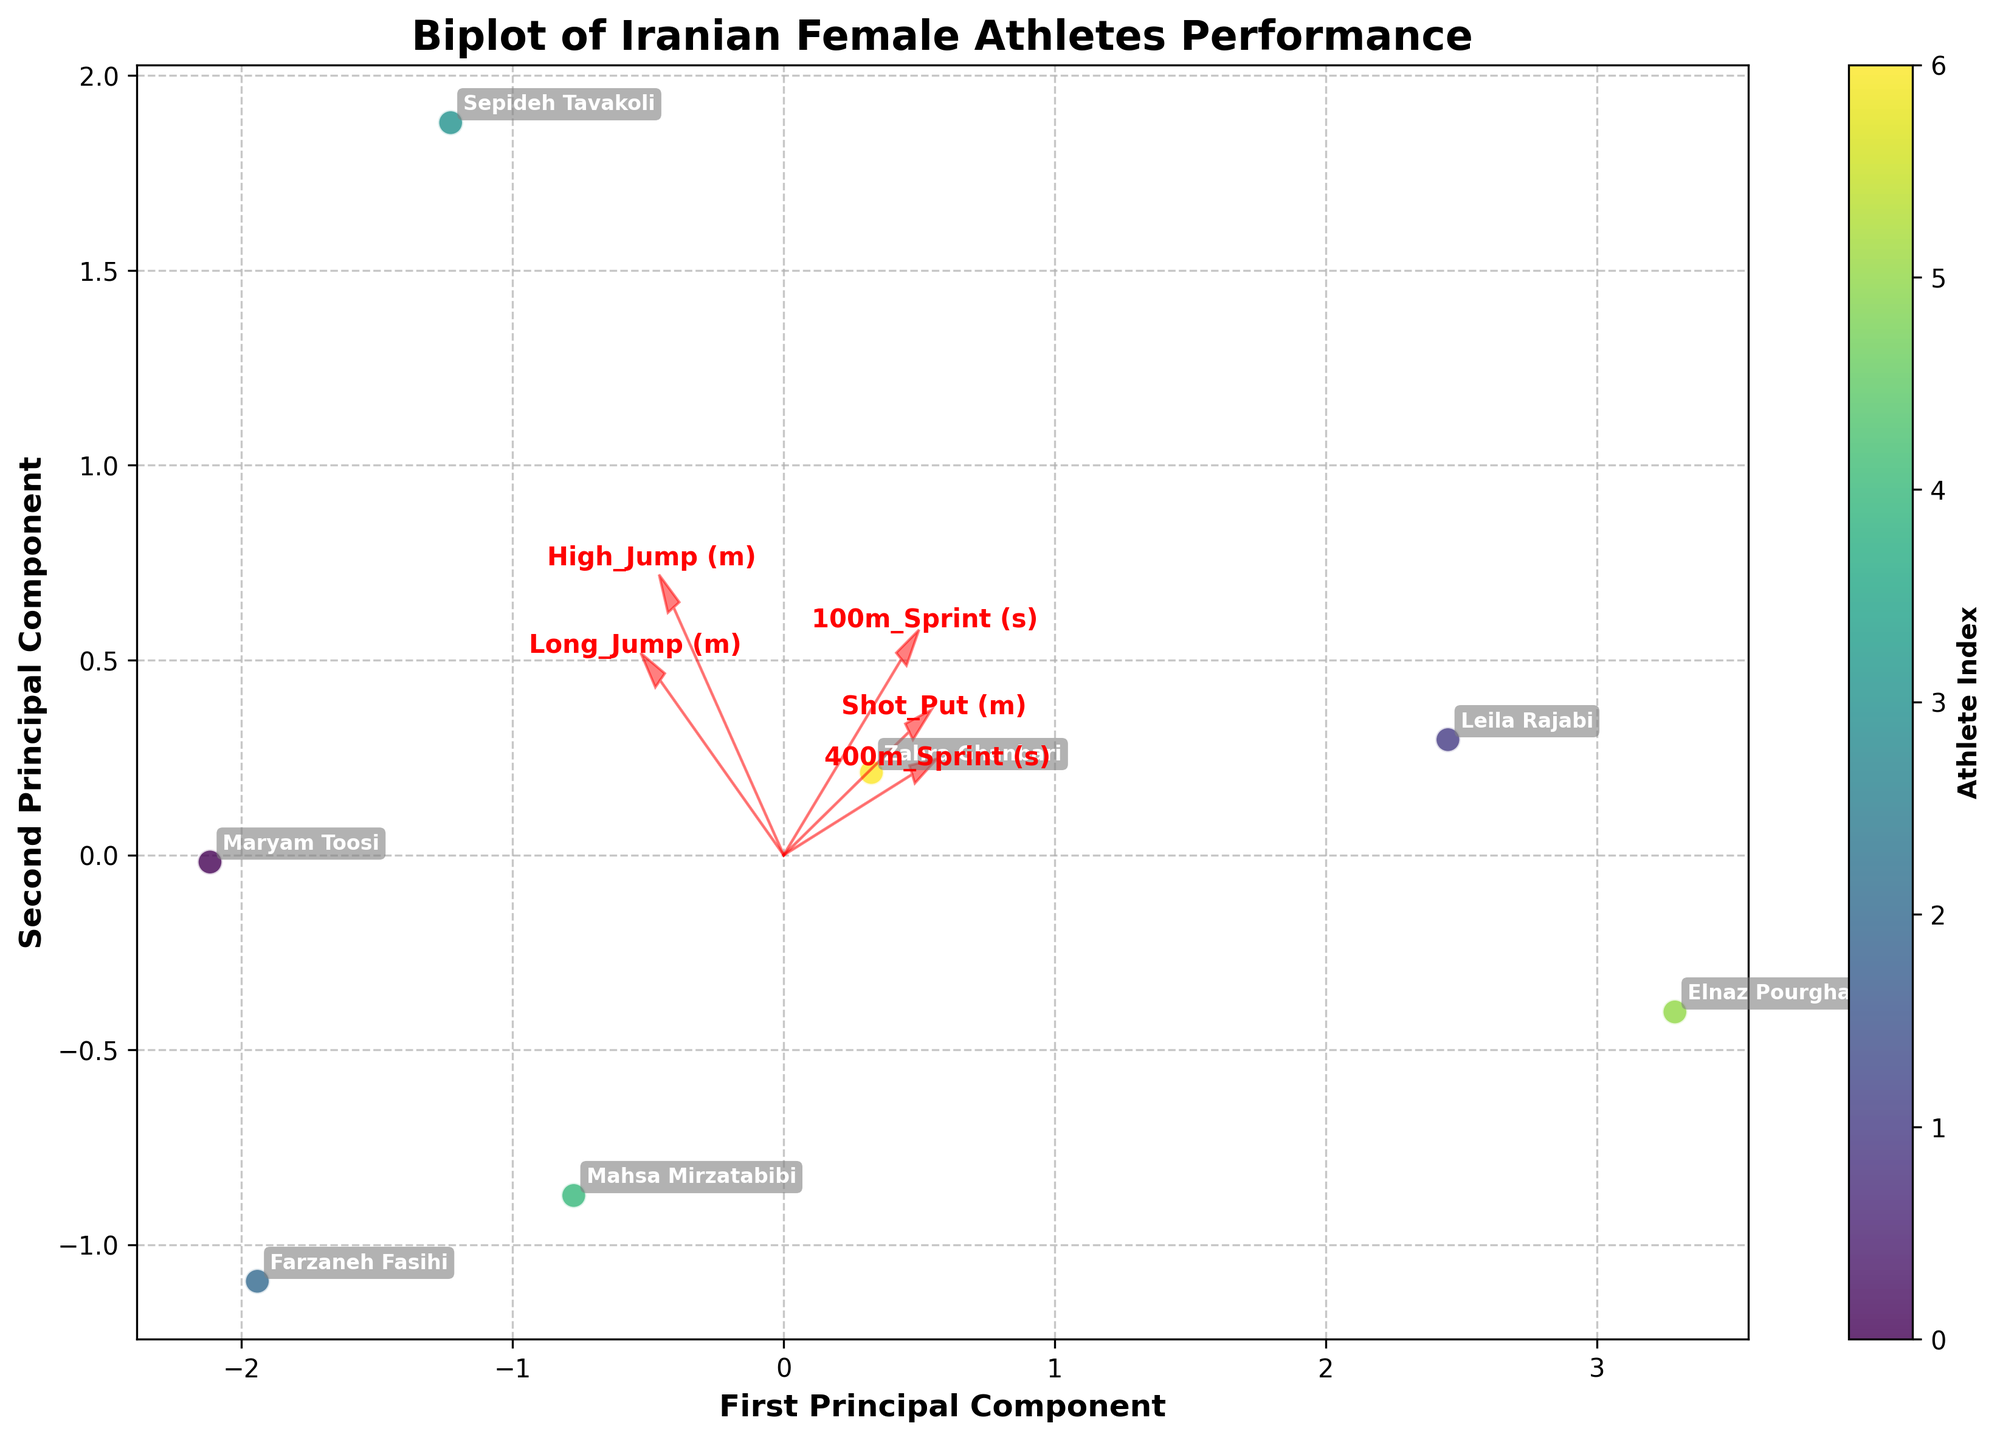What is the title of the figure? The title of the figure is typically placed at the top center of the plot. In this case, it must be read directly from the plot's top section.
Answer: Biplot of Iranian Female Athletes Performance How many athletes are represented in the plot? Count the number of different athlete names annotated on the plot.
Answer: 7 Which principal component explains more variance in the data? Compare the labeling of the x-axis (First Principal Component) and y-axis (Second Principal Component) to determine which one is the primary and secondary component.
Answer: First Principal Component Which athlete is closest to the origin of the biplot? Identify the athlete whose data point is closest to (0,0) in the biplot plot. This typically involves visually checking which point is nearest to the center.
Answer: Leila Rajabi What do the arrows in the biplot represent? Arrows in a biplot represent the feature vectors in the direction of the principal component space. In this case, they indicate how each performance metric (e.g., 100m Sprint, Long Jump) influences the principal components.
Answer: Feature vectors Which event's feature vector is the longest? Compare the lengths of all the arrows starting from the origin. Arrows pointing in the direction with longer length feature stronger alignment with principal components.
Answer: Shot_Put Which athlete has the highest influence from the 100m Sprint feature vector? The influence is directionally along the arrow of the 100m Sprint. Check which athlete's data point is farthest along the direction of the 100m Sprint arrow.
Answer: Farzaneh Fasihi Which athlete's performance shows a stronger association between Shot Put and 400m Sprint? Identify the athlete whose position is aligned along the directions of both Shot Put and 400m Sprint vectors. Visually check data points closer to the combined direction of these arrows.
Answer: Elnaz Pourghasem How are the long jump and high jump events related in the performance of athletes? Examine the angle and direction between the Long Jump and High Jump arrows. If they are closely aligned, it indicates a positive correlation between these events.
Answer: Positively correlated 